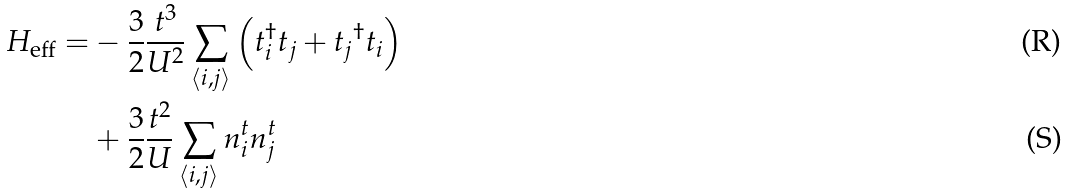Convert formula to latex. <formula><loc_0><loc_0><loc_500><loc_500>H _ { \mathrm { e f f } } = & - \frac { 3 } { 2 } \frac { t ^ { 3 } } { U ^ { 2 } } \sum _ { \langle i , j \rangle } \left ( t _ { i } ^ { \dagger } t _ { j } + t _ { j } { ^ { \dagger } } t _ { i } \right ) \\ & + \frac { 3 } { 2 } \frac { t ^ { 2 } } { U } \sum _ { \langle i , j \rangle } n ^ { t } _ { i } n ^ { t } _ { j }</formula> 